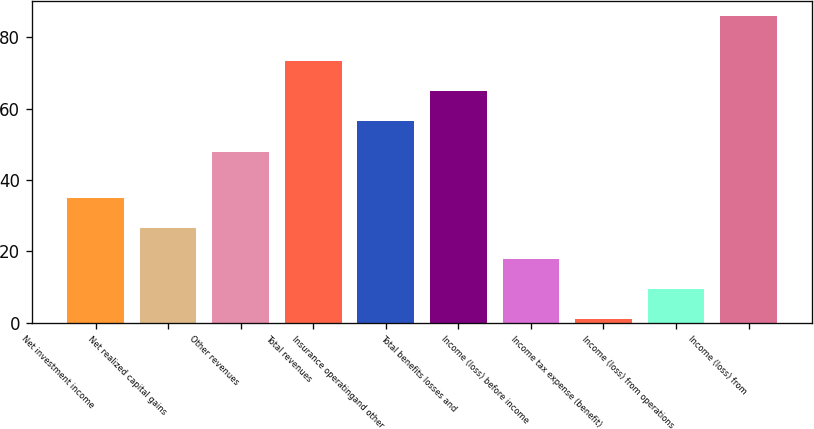Convert chart to OTSL. <chart><loc_0><loc_0><loc_500><loc_500><bar_chart><fcel>Net investment income<fcel>Net realized capital gains<fcel>Other revenues<fcel>Total revenues<fcel>Insurance operatingand other<fcel>Total benefits losses and<fcel>Income (loss) before income<fcel>Income tax expense (benefit)<fcel>Income (loss) from operations<fcel>Income (loss) from<nl><fcel>35<fcel>26.5<fcel>48<fcel>73.5<fcel>56.5<fcel>65<fcel>18<fcel>1<fcel>9.5<fcel>86<nl></chart> 